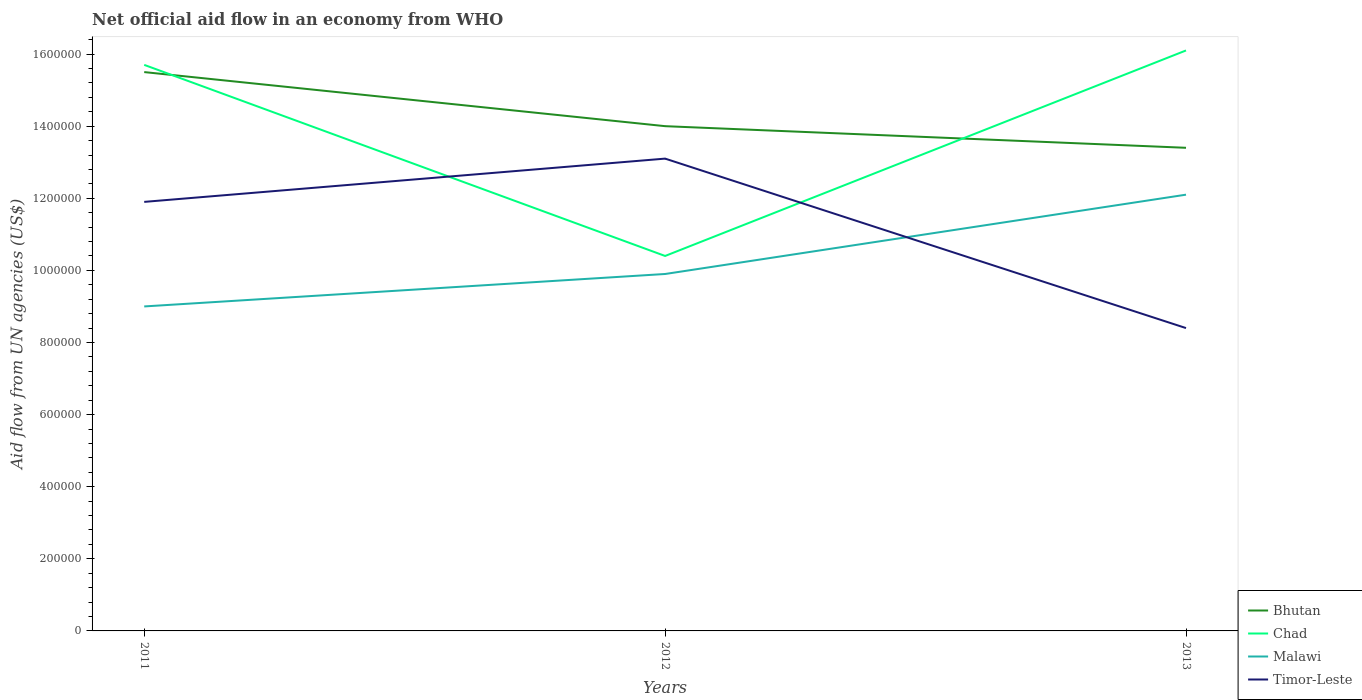How many different coloured lines are there?
Offer a terse response. 4. Does the line corresponding to Timor-Leste intersect with the line corresponding to Bhutan?
Give a very brief answer. No. Is the number of lines equal to the number of legend labels?
Ensure brevity in your answer.  Yes. Across all years, what is the maximum net official aid flow in Bhutan?
Provide a short and direct response. 1.34e+06. What is the total net official aid flow in Malawi in the graph?
Provide a succinct answer. -3.10e+05. What is the difference between the highest and the second highest net official aid flow in Chad?
Your answer should be compact. 5.70e+05. How many lines are there?
Keep it short and to the point. 4. How many years are there in the graph?
Make the answer very short. 3. What is the difference between two consecutive major ticks on the Y-axis?
Your response must be concise. 2.00e+05. Are the values on the major ticks of Y-axis written in scientific E-notation?
Make the answer very short. No. Where does the legend appear in the graph?
Provide a succinct answer. Bottom right. What is the title of the graph?
Make the answer very short. Net official aid flow in an economy from WHO. Does "Sint Maarten (Dutch part)" appear as one of the legend labels in the graph?
Provide a short and direct response. No. What is the label or title of the X-axis?
Offer a terse response. Years. What is the label or title of the Y-axis?
Offer a very short reply. Aid flow from UN agencies (US$). What is the Aid flow from UN agencies (US$) in Bhutan in 2011?
Provide a short and direct response. 1.55e+06. What is the Aid flow from UN agencies (US$) in Chad in 2011?
Give a very brief answer. 1.57e+06. What is the Aid flow from UN agencies (US$) in Malawi in 2011?
Keep it short and to the point. 9.00e+05. What is the Aid flow from UN agencies (US$) of Timor-Leste in 2011?
Provide a short and direct response. 1.19e+06. What is the Aid flow from UN agencies (US$) in Bhutan in 2012?
Offer a very short reply. 1.40e+06. What is the Aid flow from UN agencies (US$) of Chad in 2012?
Your response must be concise. 1.04e+06. What is the Aid flow from UN agencies (US$) of Malawi in 2012?
Give a very brief answer. 9.90e+05. What is the Aid flow from UN agencies (US$) in Timor-Leste in 2012?
Offer a terse response. 1.31e+06. What is the Aid flow from UN agencies (US$) in Bhutan in 2013?
Your answer should be very brief. 1.34e+06. What is the Aid flow from UN agencies (US$) of Chad in 2013?
Offer a very short reply. 1.61e+06. What is the Aid flow from UN agencies (US$) in Malawi in 2013?
Make the answer very short. 1.21e+06. What is the Aid flow from UN agencies (US$) in Timor-Leste in 2013?
Ensure brevity in your answer.  8.40e+05. Across all years, what is the maximum Aid flow from UN agencies (US$) of Bhutan?
Offer a very short reply. 1.55e+06. Across all years, what is the maximum Aid flow from UN agencies (US$) of Chad?
Give a very brief answer. 1.61e+06. Across all years, what is the maximum Aid flow from UN agencies (US$) in Malawi?
Your answer should be compact. 1.21e+06. Across all years, what is the maximum Aid flow from UN agencies (US$) in Timor-Leste?
Keep it short and to the point. 1.31e+06. Across all years, what is the minimum Aid flow from UN agencies (US$) in Bhutan?
Keep it short and to the point. 1.34e+06. Across all years, what is the minimum Aid flow from UN agencies (US$) of Chad?
Keep it short and to the point. 1.04e+06. Across all years, what is the minimum Aid flow from UN agencies (US$) of Timor-Leste?
Offer a very short reply. 8.40e+05. What is the total Aid flow from UN agencies (US$) of Bhutan in the graph?
Give a very brief answer. 4.29e+06. What is the total Aid flow from UN agencies (US$) in Chad in the graph?
Keep it short and to the point. 4.22e+06. What is the total Aid flow from UN agencies (US$) of Malawi in the graph?
Offer a very short reply. 3.10e+06. What is the total Aid flow from UN agencies (US$) of Timor-Leste in the graph?
Your answer should be very brief. 3.34e+06. What is the difference between the Aid flow from UN agencies (US$) of Chad in 2011 and that in 2012?
Your answer should be compact. 5.30e+05. What is the difference between the Aid flow from UN agencies (US$) of Timor-Leste in 2011 and that in 2012?
Make the answer very short. -1.20e+05. What is the difference between the Aid flow from UN agencies (US$) in Malawi in 2011 and that in 2013?
Keep it short and to the point. -3.10e+05. What is the difference between the Aid flow from UN agencies (US$) of Chad in 2012 and that in 2013?
Ensure brevity in your answer.  -5.70e+05. What is the difference between the Aid flow from UN agencies (US$) in Timor-Leste in 2012 and that in 2013?
Ensure brevity in your answer.  4.70e+05. What is the difference between the Aid flow from UN agencies (US$) of Bhutan in 2011 and the Aid flow from UN agencies (US$) of Chad in 2012?
Make the answer very short. 5.10e+05. What is the difference between the Aid flow from UN agencies (US$) in Bhutan in 2011 and the Aid flow from UN agencies (US$) in Malawi in 2012?
Your answer should be very brief. 5.60e+05. What is the difference between the Aid flow from UN agencies (US$) of Chad in 2011 and the Aid flow from UN agencies (US$) of Malawi in 2012?
Ensure brevity in your answer.  5.80e+05. What is the difference between the Aid flow from UN agencies (US$) in Chad in 2011 and the Aid flow from UN agencies (US$) in Timor-Leste in 2012?
Provide a short and direct response. 2.60e+05. What is the difference between the Aid flow from UN agencies (US$) of Malawi in 2011 and the Aid flow from UN agencies (US$) of Timor-Leste in 2012?
Your response must be concise. -4.10e+05. What is the difference between the Aid flow from UN agencies (US$) of Bhutan in 2011 and the Aid flow from UN agencies (US$) of Chad in 2013?
Provide a succinct answer. -6.00e+04. What is the difference between the Aid flow from UN agencies (US$) in Bhutan in 2011 and the Aid flow from UN agencies (US$) in Malawi in 2013?
Your response must be concise. 3.40e+05. What is the difference between the Aid flow from UN agencies (US$) of Bhutan in 2011 and the Aid flow from UN agencies (US$) of Timor-Leste in 2013?
Keep it short and to the point. 7.10e+05. What is the difference between the Aid flow from UN agencies (US$) of Chad in 2011 and the Aid flow from UN agencies (US$) of Timor-Leste in 2013?
Keep it short and to the point. 7.30e+05. What is the difference between the Aid flow from UN agencies (US$) of Malawi in 2011 and the Aid flow from UN agencies (US$) of Timor-Leste in 2013?
Offer a very short reply. 6.00e+04. What is the difference between the Aid flow from UN agencies (US$) in Bhutan in 2012 and the Aid flow from UN agencies (US$) in Chad in 2013?
Ensure brevity in your answer.  -2.10e+05. What is the difference between the Aid flow from UN agencies (US$) in Bhutan in 2012 and the Aid flow from UN agencies (US$) in Timor-Leste in 2013?
Your answer should be very brief. 5.60e+05. What is the difference between the Aid flow from UN agencies (US$) in Malawi in 2012 and the Aid flow from UN agencies (US$) in Timor-Leste in 2013?
Provide a succinct answer. 1.50e+05. What is the average Aid flow from UN agencies (US$) of Bhutan per year?
Provide a succinct answer. 1.43e+06. What is the average Aid flow from UN agencies (US$) of Chad per year?
Give a very brief answer. 1.41e+06. What is the average Aid flow from UN agencies (US$) of Malawi per year?
Keep it short and to the point. 1.03e+06. What is the average Aid flow from UN agencies (US$) in Timor-Leste per year?
Offer a very short reply. 1.11e+06. In the year 2011, what is the difference between the Aid flow from UN agencies (US$) in Bhutan and Aid flow from UN agencies (US$) in Malawi?
Your answer should be very brief. 6.50e+05. In the year 2011, what is the difference between the Aid flow from UN agencies (US$) in Bhutan and Aid flow from UN agencies (US$) in Timor-Leste?
Your answer should be compact. 3.60e+05. In the year 2011, what is the difference between the Aid flow from UN agencies (US$) of Chad and Aid flow from UN agencies (US$) of Malawi?
Offer a terse response. 6.70e+05. In the year 2012, what is the difference between the Aid flow from UN agencies (US$) of Bhutan and Aid flow from UN agencies (US$) of Malawi?
Provide a short and direct response. 4.10e+05. In the year 2012, what is the difference between the Aid flow from UN agencies (US$) of Bhutan and Aid flow from UN agencies (US$) of Timor-Leste?
Your answer should be compact. 9.00e+04. In the year 2012, what is the difference between the Aid flow from UN agencies (US$) in Chad and Aid flow from UN agencies (US$) in Malawi?
Make the answer very short. 5.00e+04. In the year 2012, what is the difference between the Aid flow from UN agencies (US$) in Chad and Aid flow from UN agencies (US$) in Timor-Leste?
Keep it short and to the point. -2.70e+05. In the year 2012, what is the difference between the Aid flow from UN agencies (US$) of Malawi and Aid flow from UN agencies (US$) of Timor-Leste?
Your response must be concise. -3.20e+05. In the year 2013, what is the difference between the Aid flow from UN agencies (US$) in Bhutan and Aid flow from UN agencies (US$) in Chad?
Give a very brief answer. -2.70e+05. In the year 2013, what is the difference between the Aid flow from UN agencies (US$) of Bhutan and Aid flow from UN agencies (US$) of Timor-Leste?
Give a very brief answer. 5.00e+05. In the year 2013, what is the difference between the Aid flow from UN agencies (US$) of Chad and Aid flow from UN agencies (US$) of Malawi?
Ensure brevity in your answer.  4.00e+05. In the year 2013, what is the difference between the Aid flow from UN agencies (US$) in Chad and Aid flow from UN agencies (US$) in Timor-Leste?
Offer a very short reply. 7.70e+05. In the year 2013, what is the difference between the Aid flow from UN agencies (US$) in Malawi and Aid flow from UN agencies (US$) in Timor-Leste?
Make the answer very short. 3.70e+05. What is the ratio of the Aid flow from UN agencies (US$) in Bhutan in 2011 to that in 2012?
Your answer should be very brief. 1.11. What is the ratio of the Aid flow from UN agencies (US$) of Chad in 2011 to that in 2012?
Offer a terse response. 1.51. What is the ratio of the Aid flow from UN agencies (US$) of Timor-Leste in 2011 to that in 2012?
Make the answer very short. 0.91. What is the ratio of the Aid flow from UN agencies (US$) in Bhutan in 2011 to that in 2013?
Your answer should be very brief. 1.16. What is the ratio of the Aid flow from UN agencies (US$) in Chad in 2011 to that in 2013?
Keep it short and to the point. 0.98. What is the ratio of the Aid flow from UN agencies (US$) in Malawi in 2011 to that in 2013?
Ensure brevity in your answer.  0.74. What is the ratio of the Aid flow from UN agencies (US$) in Timor-Leste in 2011 to that in 2013?
Your response must be concise. 1.42. What is the ratio of the Aid flow from UN agencies (US$) of Bhutan in 2012 to that in 2013?
Give a very brief answer. 1.04. What is the ratio of the Aid flow from UN agencies (US$) of Chad in 2012 to that in 2013?
Provide a succinct answer. 0.65. What is the ratio of the Aid flow from UN agencies (US$) of Malawi in 2012 to that in 2013?
Ensure brevity in your answer.  0.82. What is the ratio of the Aid flow from UN agencies (US$) in Timor-Leste in 2012 to that in 2013?
Your response must be concise. 1.56. What is the difference between the highest and the second highest Aid flow from UN agencies (US$) in Bhutan?
Your answer should be compact. 1.50e+05. What is the difference between the highest and the lowest Aid flow from UN agencies (US$) of Bhutan?
Provide a short and direct response. 2.10e+05. What is the difference between the highest and the lowest Aid flow from UN agencies (US$) in Chad?
Your answer should be compact. 5.70e+05. What is the difference between the highest and the lowest Aid flow from UN agencies (US$) in Timor-Leste?
Make the answer very short. 4.70e+05. 